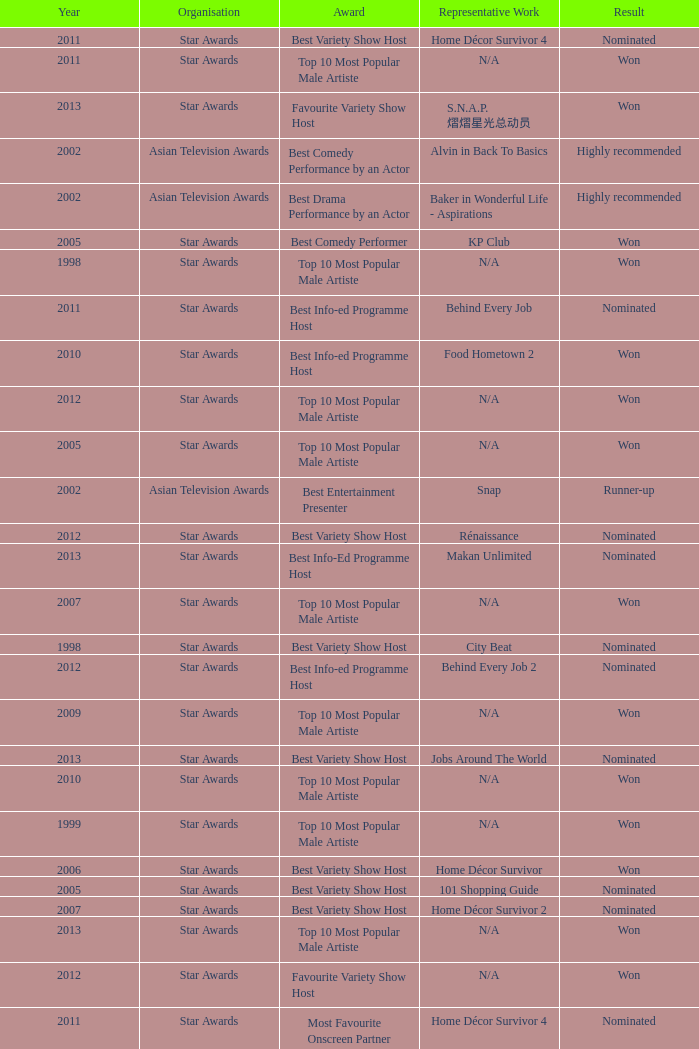Parse the table in full. {'header': ['Year', 'Organisation', 'Award', 'Representative Work', 'Result'], 'rows': [['2011', 'Star Awards', 'Best Variety Show Host', 'Home Décor Survivor 4', 'Nominated'], ['2011', 'Star Awards', 'Top 10 Most Popular Male Artiste', 'N/A', 'Won'], ['2013', 'Star Awards', 'Favourite Variety Show Host', 'S.N.A.P. 熠熠星光总动员', 'Won'], ['2002', 'Asian Television Awards', 'Best Comedy Performance by an Actor', 'Alvin in Back To Basics', 'Highly recommended'], ['2002', 'Asian Television Awards', 'Best Drama Performance by an Actor', 'Baker in Wonderful Life - Aspirations', 'Highly recommended'], ['2005', 'Star Awards', 'Best Comedy Performer', 'KP Club', 'Won'], ['1998', 'Star Awards', 'Top 10 Most Popular Male Artiste', 'N/A', 'Won'], ['2011', 'Star Awards', 'Best Info-ed Programme Host', 'Behind Every Job', 'Nominated'], ['2010', 'Star Awards', 'Best Info-ed Programme Host', 'Food Hometown 2', 'Won'], ['2012', 'Star Awards', 'Top 10 Most Popular Male Artiste', 'N/A', 'Won'], ['2005', 'Star Awards', 'Top 10 Most Popular Male Artiste', 'N/A', 'Won'], ['2002', 'Asian Television Awards', 'Best Entertainment Presenter', 'Snap', 'Runner-up'], ['2012', 'Star Awards', 'Best Variety Show Host', 'Rénaissance', 'Nominated'], ['2013', 'Star Awards', 'Best Info-Ed Programme Host', 'Makan Unlimited', 'Nominated'], ['2007', 'Star Awards', 'Top 10 Most Popular Male Artiste', 'N/A', 'Won'], ['1998', 'Star Awards', 'Best Variety Show Host', 'City Beat', 'Nominated'], ['2012', 'Star Awards', 'Best Info-ed Programme Host', 'Behind Every Job 2', 'Nominated'], ['2009', 'Star Awards', 'Top 10 Most Popular Male Artiste', 'N/A', 'Won'], ['2013', 'Star Awards', 'Best Variety Show Host', 'Jobs Around The World', 'Nominated'], ['2010', 'Star Awards', 'Top 10 Most Popular Male Artiste', 'N/A', 'Won'], ['1999', 'Star Awards', 'Top 10 Most Popular Male Artiste', 'N/A', 'Won'], ['2006', 'Star Awards', 'Best Variety Show Host', 'Home Décor Survivor', 'Won'], ['2005', 'Star Awards', 'Best Variety Show Host', '101 Shopping Guide', 'Nominated'], ['2007', 'Star Awards', 'Best Variety Show Host', 'Home Décor Survivor 2', 'Nominated'], ['2013', 'Star Awards', 'Top 10 Most Popular Male Artiste', 'N/A', 'Won'], ['2012', 'Star Awards', 'Favourite Variety Show Host', 'N/A', 'Won'], ['2011', 'Star Awards', 'Most Favourite Onscreen Partner (Variety)', 'Home Décor Survivor 4', 'Nominated'], ['2006', 'Star Awards', 'Top 10 Most Popular Male Artiste', 'N/A', 'Won']]} What is the name of the award in a year more than 2005, and the Result of nominated? Best Variety Show Host, Most Favourite Onscreen Partner (Variety), Best Variety Show Host, Best Info-ed Programme Host, Best Variety Show Host, Best Info-ed Programme Host, Best Info-Ed Programme Host, Best Variety Show Host. 